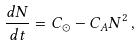Convert formula to latex. <formula><loc_0><loc_0><loc_500><loc_500>\frac { d N } { d t } = C _ { \odot } - C _ { A } N ^ { 2 } \, ,</formula> 